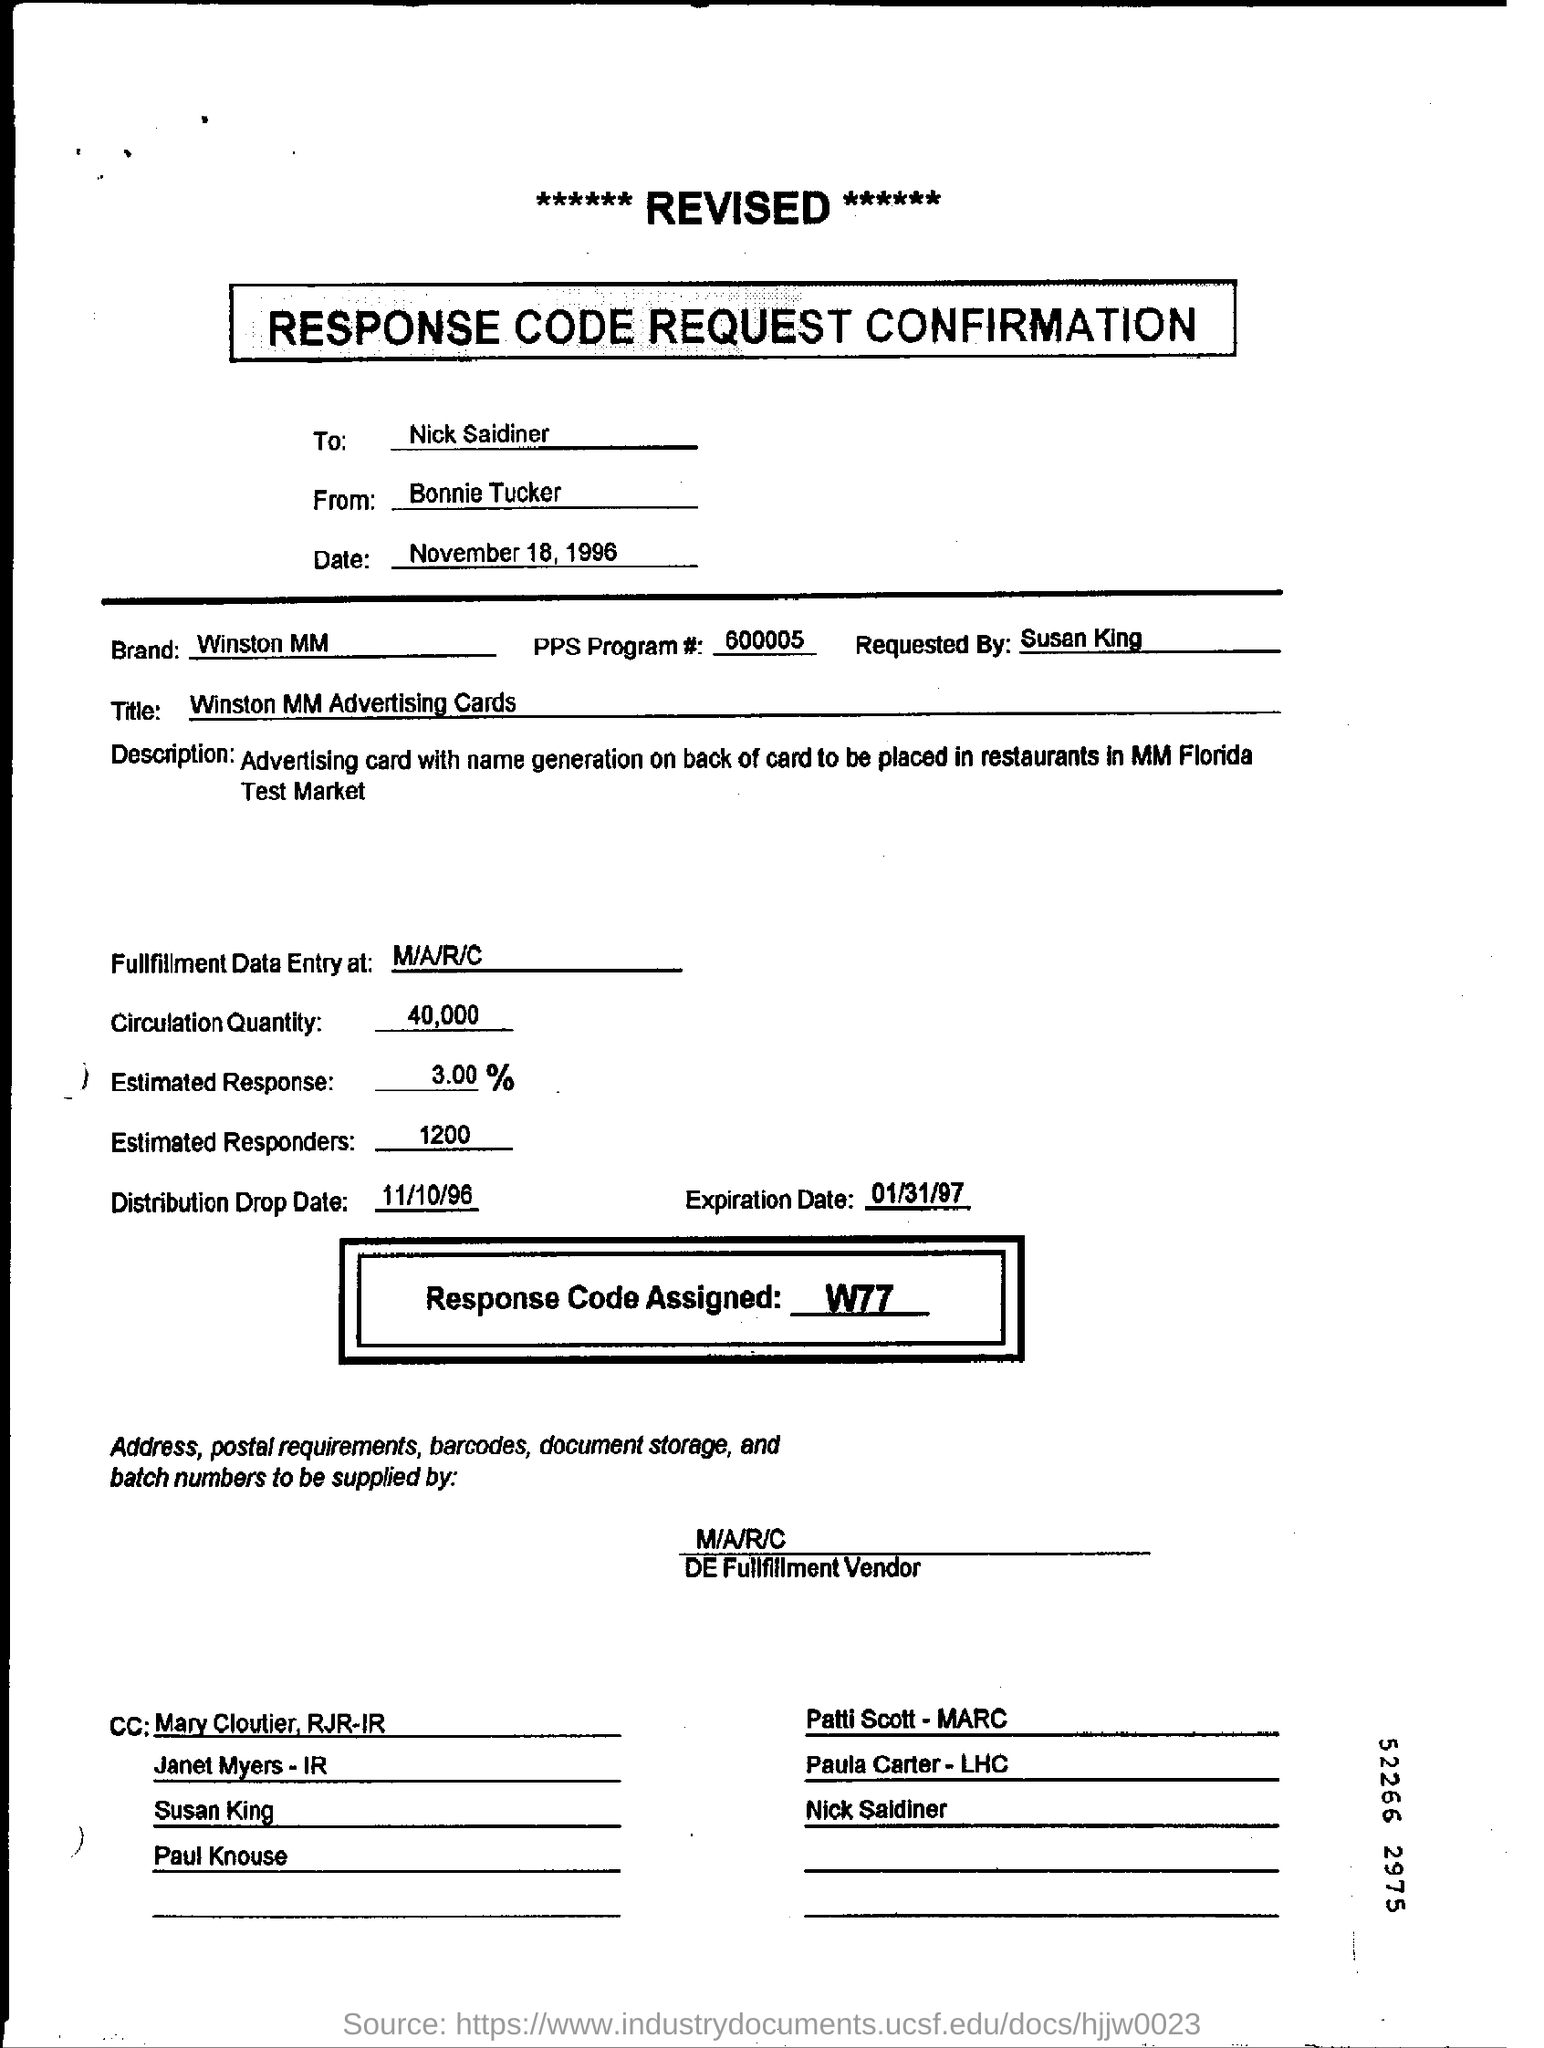Identify some key points in this picture. The distribution drop date is October 11th, 1996. The recipient of the confirmation is Nick Saidiner. The response code that is assigned is W77.. The quantity of circulation is 40,000. 